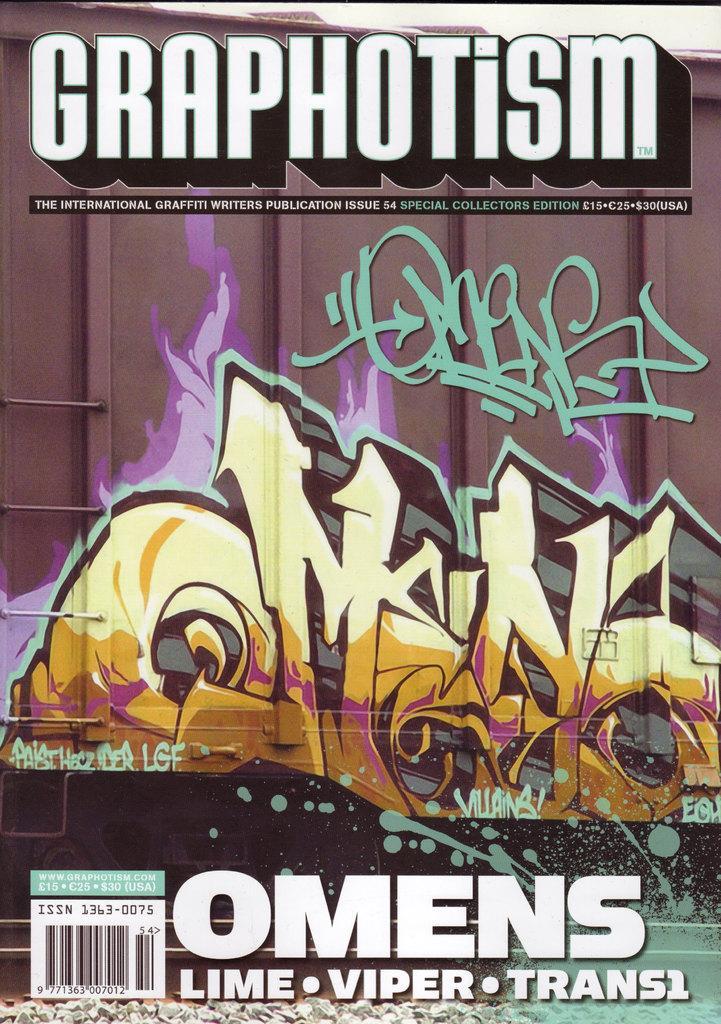Could you give a brief overview of what you see in this image? This image consists of a poster on which I can see some painting and text. 